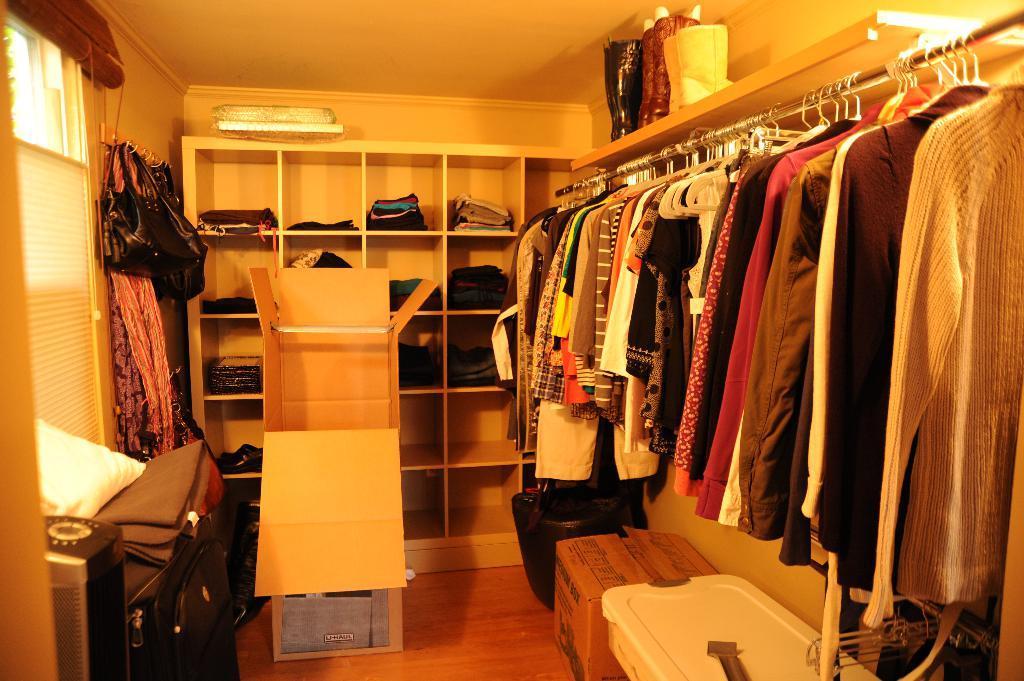In one or two sentences, can you explain what this image depicts? In this image we can see a closet. Image also consists of bags, card board, a white color box and also clothes placed inside the rack. At the top there is ceiling and at the bottom there is floor. 